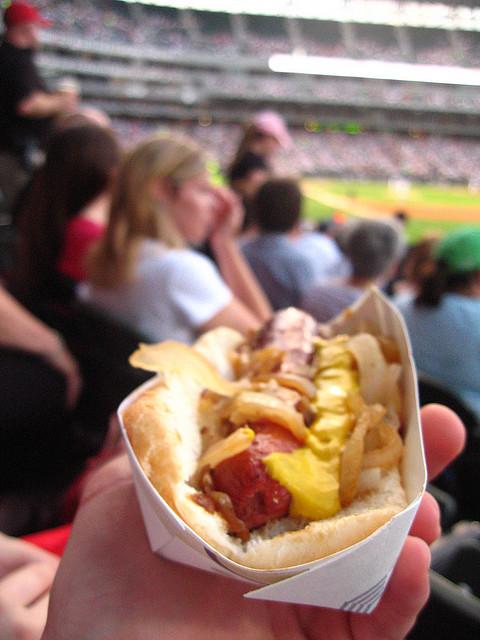What food is in the picture?
Be succinct. Hot dog. Are the onions cooked on the hot dog?
Keep it brief. Yes. What is on the hot dog?
Be succinct. Mustard. Has part of the hot dog been eaten?
Quick response, please. No. Did they use ketchup?
Short answer required. No. Is there relish on this hot dog?
Answer briefly. No. Is the hot dog on a paper plate?
Keep it brief. Yes. Does the picture portray a whole or partial sandwich?
Write a very short answer. Whole. Where is the food?
Short answer required. In hand. 